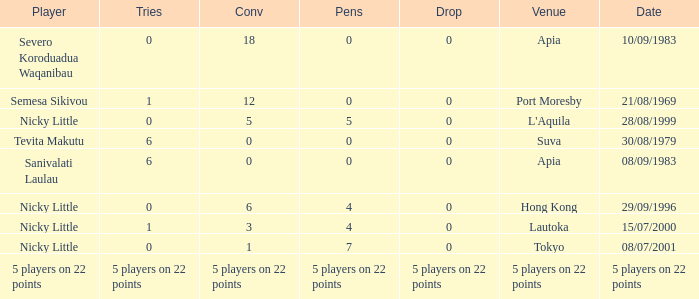How many conversions did Severo Koroduadua Waqanibau have when he has 0 pens? 18.0. 